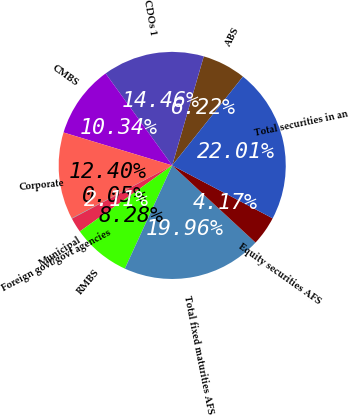<chart> <loc_0><loc_0><loc_500><loc_500><pie_chart><fcel>ABS<fcel>CDOs 1<fcel>CMBS<fcel>Corporate<fcel>Foreign govt/govt agencies<fcel>Municipal<fcel>RMBS<fcel>Total fixed maturities AFS<fcel>Equity securities AFS<fcel>Total securities in an<nl><fcel>6.22%<fcel>14.46%<fcel>10.34%<fcel>12.4%<fcel>0.05%<fcel>2.11%<fcel>8.28%<fcel>19.96%<fcel>4.17%<fcel>22.01%<nl></chart> 